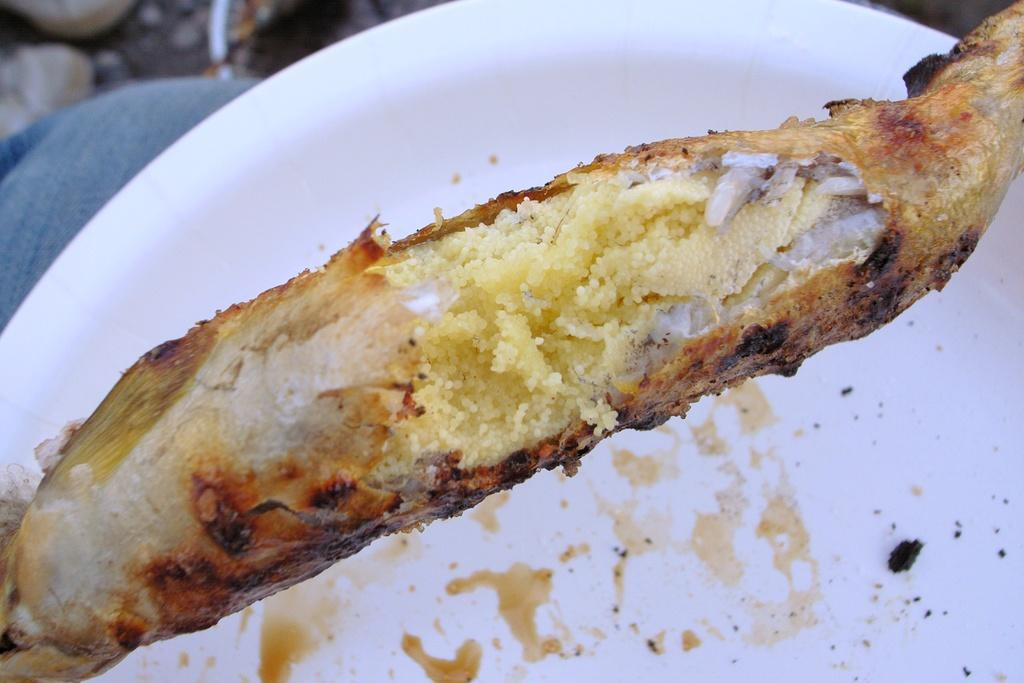What is the main subject of the image? There is a food item in the image. What is the food item placed on? There is a white plate underneath the food item. How many dimes are visible on the plate in the image? There are no dimes present in the image; it only features a food item and a white plate. What type of loss is depicted in the image? There is no loss depicted in the image; it only features a food item and a white plate. 